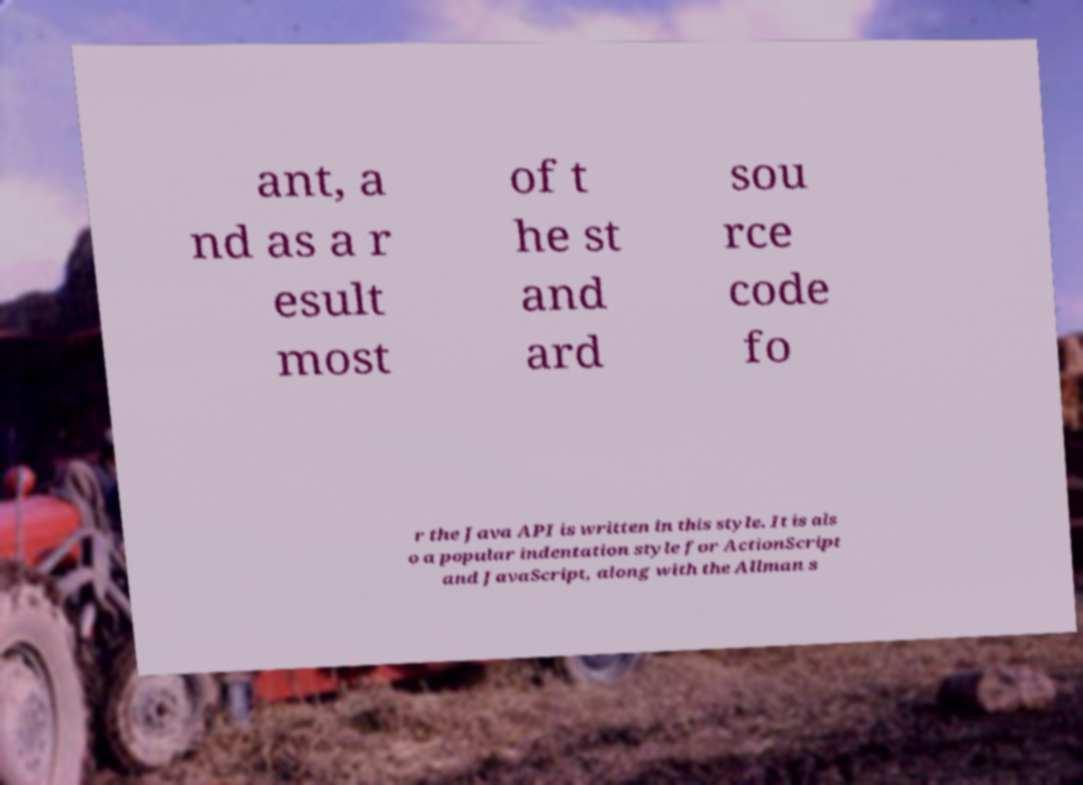Please identify and transcribe the text found in this image. ant, a nd as a r esult most of t he st and ard sou rce code fo r the Java API is written in this style. It is als o a popular indentation style for ActionScript and JavaScript, along with the Allman s 